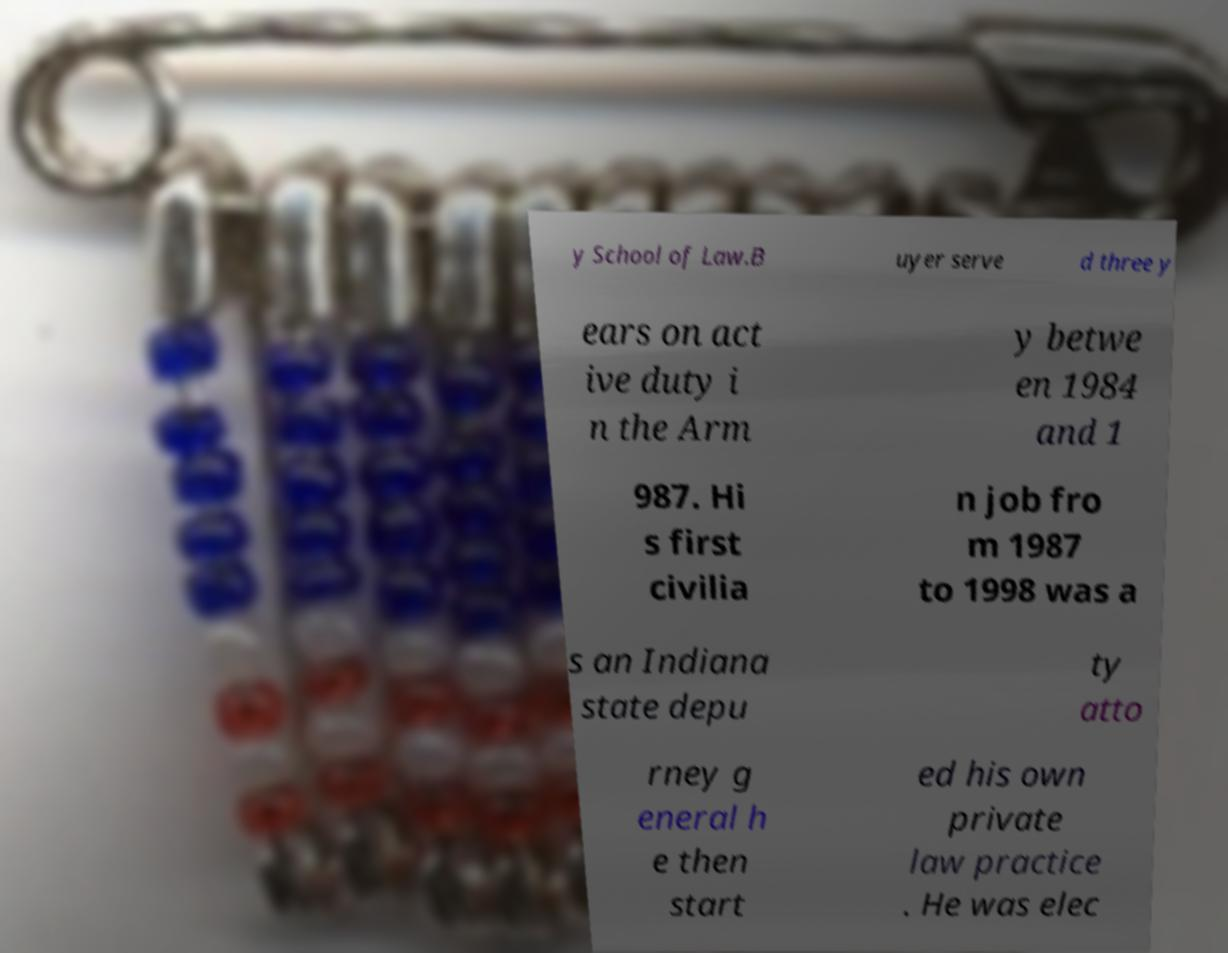For documentation purposes, I need the text within this image transcribed. Could you provide that? y School of Law.B uyer serve d three y ears on act ive duty i n the Arm y betwe en 1984 and 1 987. Hi s first civilia n job fro m 1987 to 1998 was a s an Indiana state depu ty atto rney g eneral h e then start ed his own private law practice . He was elec 